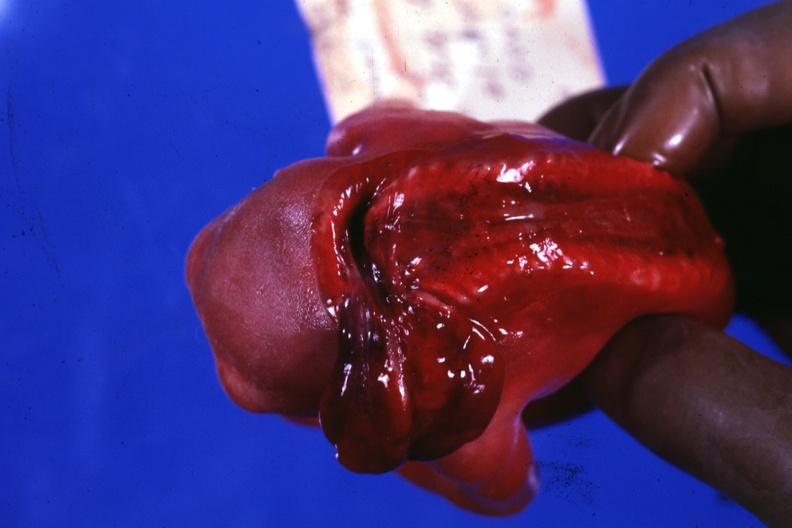what is present?
Answer the question using a single word or phrase. Anencephaly 